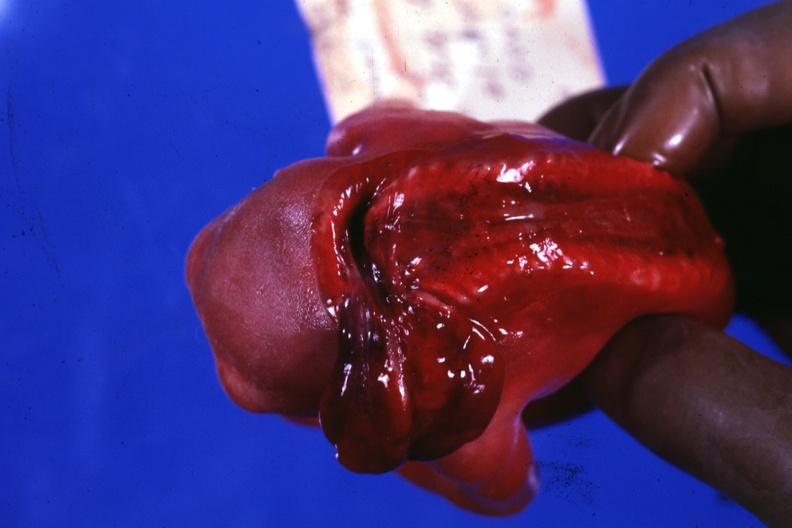what is present?
Answer the question using a single word or phrase. Anencephaly 